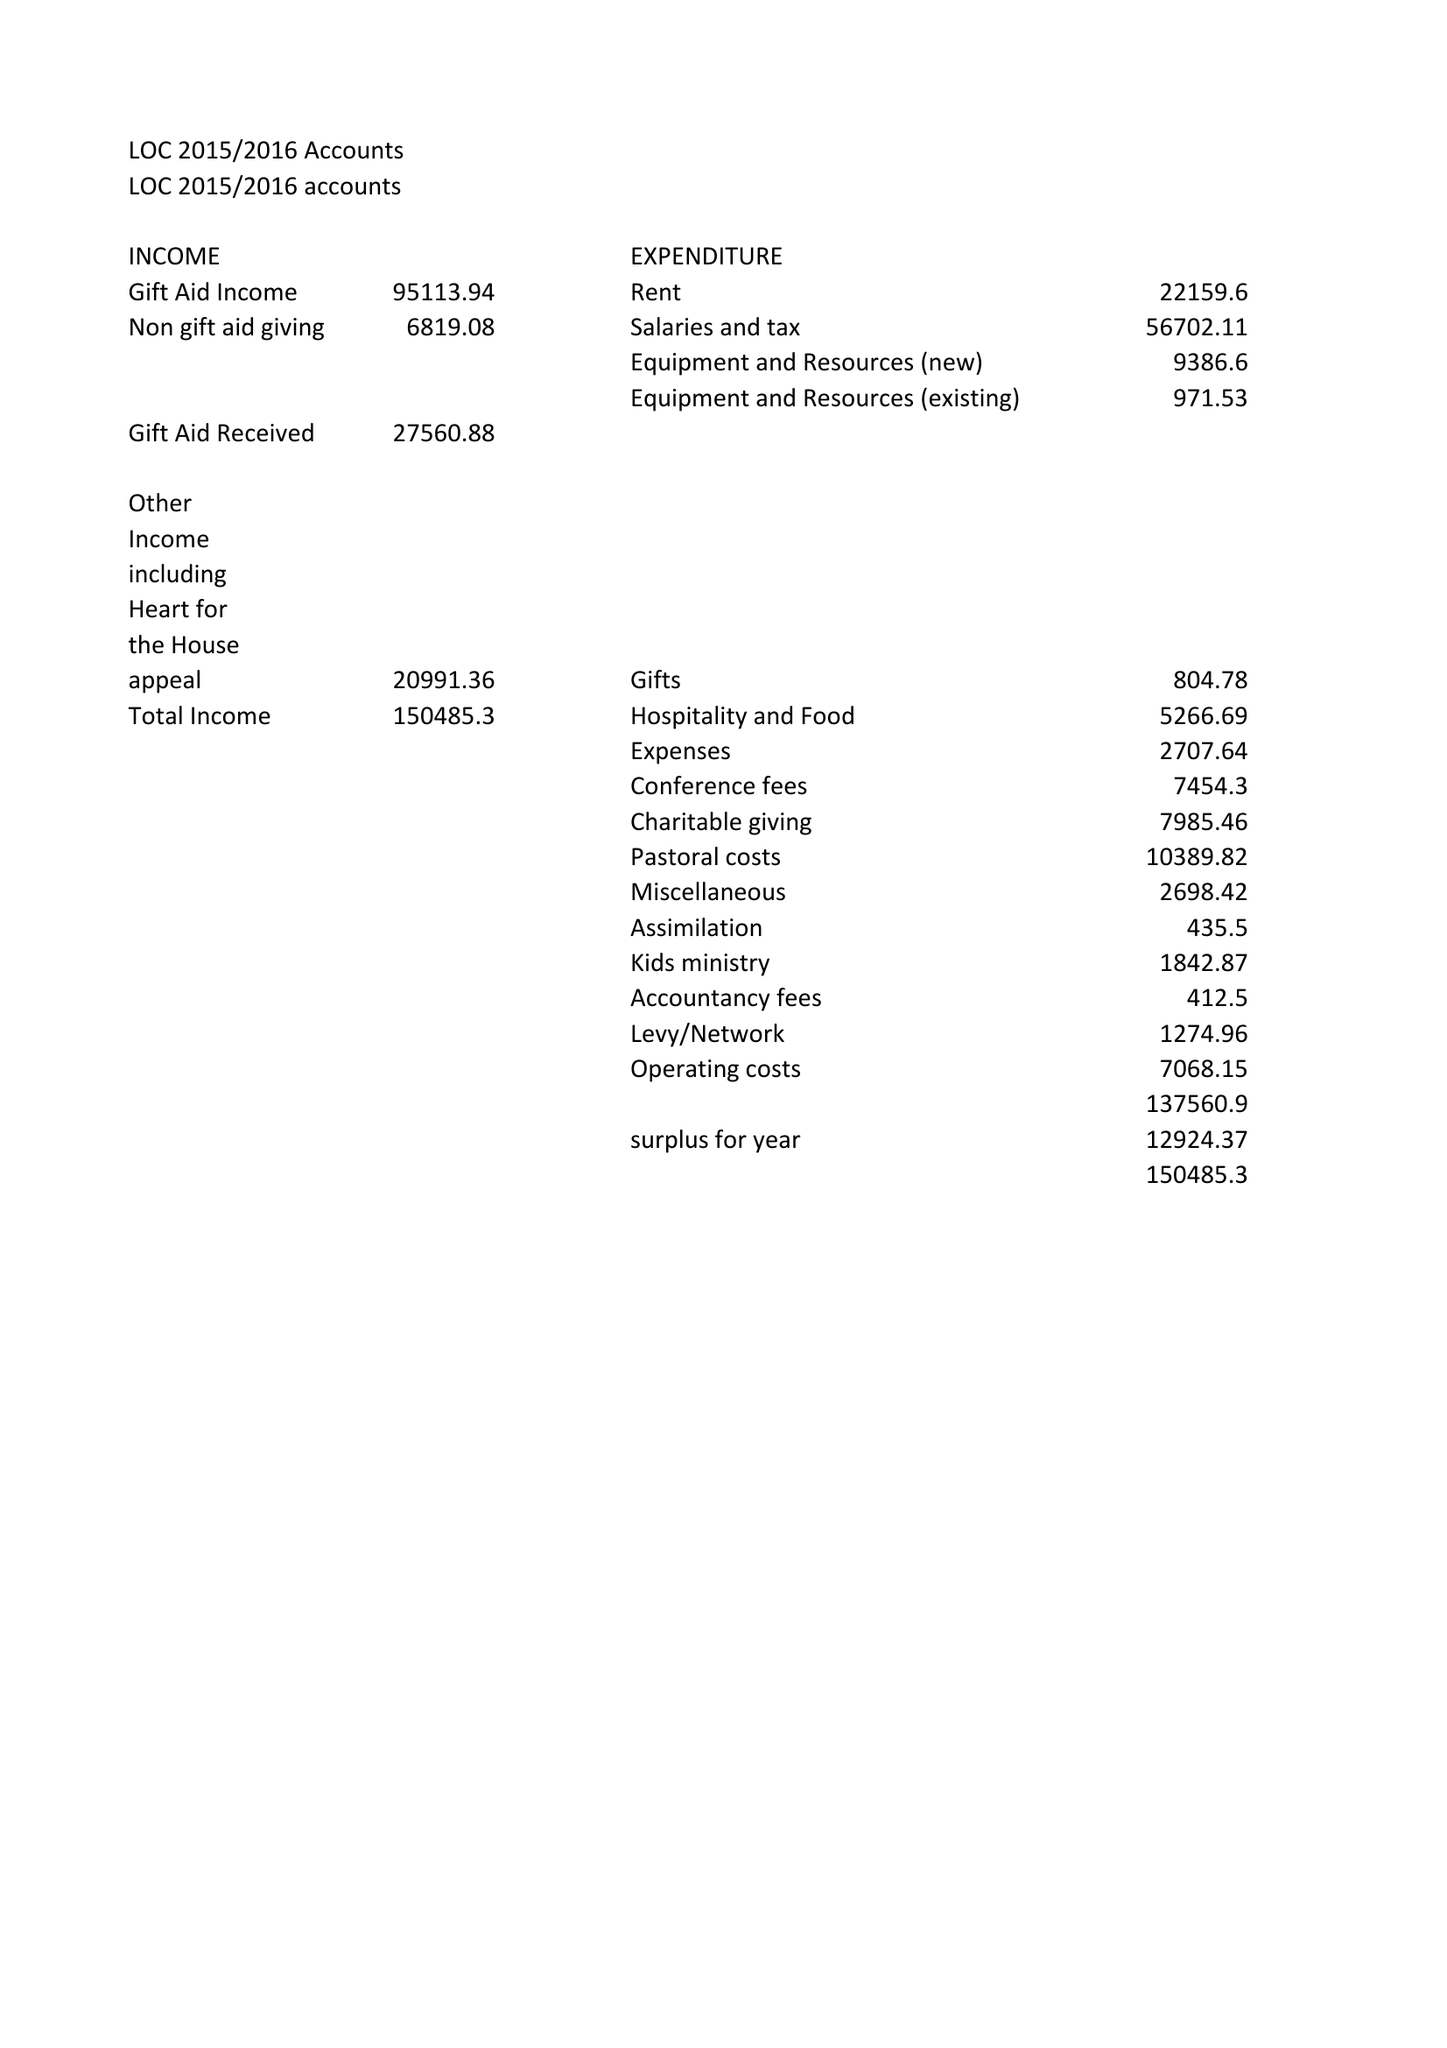What is the value for the report_date?
Answer the question using a single word or phrase. 2016-03-31 